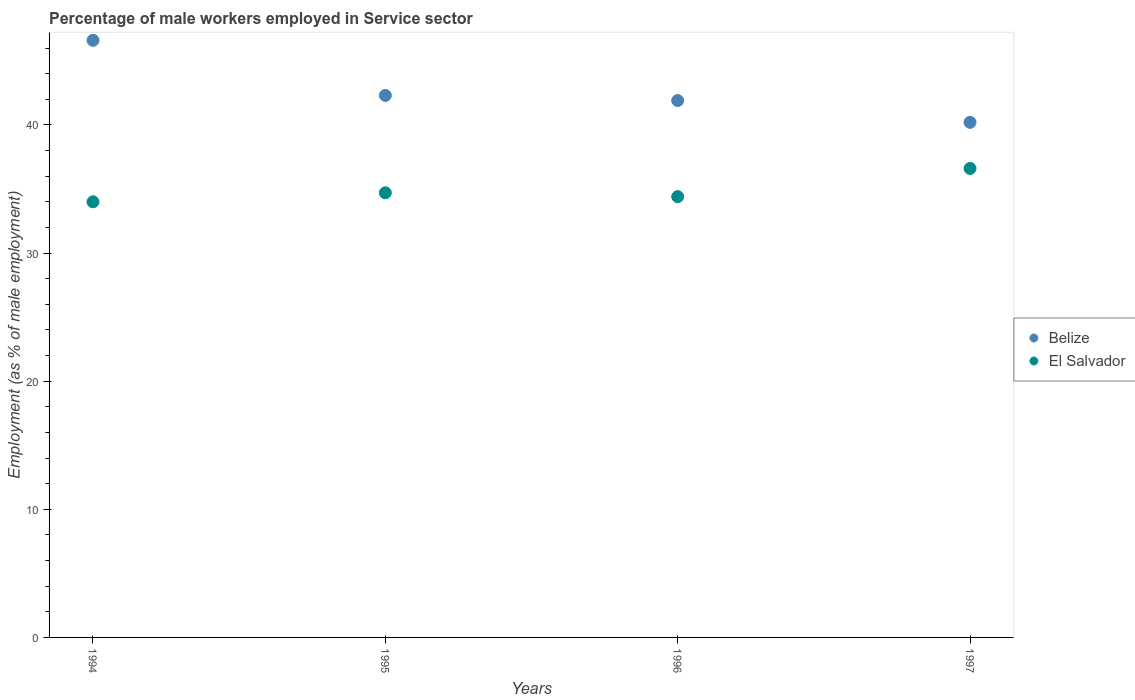How many different coloured dotlines are there?
Your response must be concise. 2. What is the percentage of male workers employed in Service sector in El Salvador in 1997?
Give a very brief answer. 36.6. Across all years, what is the maximum percentage of male workers employed in Service sector in El Salvador?
Offer a terse response. 36.6. Across all years, what is the minimum percentage of male workers employed in Service sector in Belize?
Your answer should be very brief. 40.2. What is the total percentage of male workers employed in Service sector in El Salvador in the graph?
Your answer should be very brief. 139.7. What is the difference between the percentage of male workers employed in Service sector in Belize in 1995 and that in 1997?
Provide a short and direct response. 2.1. What is the difference between the percentage of male workers employed in Service sector in Belize in 1994 and the percentage of male workers employed in Service sector in El Salvador in 1997?
Keep it short and to the point. 10. What is the average percentage of male workers employed in Service sector in Belize per year?
Offer a very short reply. 42.75. What is the ratio of the percentage of male workers employed in Service sector in Belize in 1995 to that in 1997?
Ensure brevity in your answer.  1.05. What is the difference between the highest and the second highest percentage of male workers employed in Service sector in El Salvador?
Make the answer very short. 1.9. What is the difference between the highest and the lowest percentage of male workers employed in Service sector in Belize?
Your answer should be compact. 6.4. Is the sum of the percentage of male workers employed in Service sector in El Salvador in 1994 and 1996 greater than the maximum percentage of male workers employed in Service sector in Belize across all years?
Give a very brief answer. Yes. How many dotlines are there?
Your answer should be very brief. 2. How many years are there in the graph?
Your answer should be compact. 4. Are the values on the major ticks of Y-axis written in scientific E-notation?
Your answer should be compact. No. Does the graph contain grids?
Your answer should be very brief. No. Where does the legend appear in the graph?
Your answer should be compact. Center right. How many legend labels are there?
Provide a succinct answer. 2. What is the title of the graph?
Offer a very short reply. Percentage of male workers employed in Service sector. What is the label or title of the Y-axis?
Make the answer very short. Employment (as % of male employment). What is the Employment (as % of male employment) of Belize in 1994?
Offer a very short reply. 46.6. What is the Employment (as % of male employment) of El Salvador in 1994?
Your response must be concise. 34. What is the Employment (as % of male employment) of Belize in 1995?
Your answer should be compact. 42.3. What is the Employment (as % of male employment) in El Salvador in 1995?
Offer a very short reply. 34.7. What is the Employment (as % of male employment) of Belize in 1996?
Your response must be concise. 41.9. What is the Employment (as % of male employment) in El Salvador in 1996?
Offer a terse response. 34.4. What is the Employment (as % of male employment) of Belize in 1997?
Give a very brief answer. 40.2. What is the Employment (as % of male employment) in El Salvador in 1997?
Make the answer very short. 36.6. Across all years, what is the maximum Employment (as % of male employment) in Belize?
Your response must be concise. 46.6. Across all years, what is the maximum Employment (as % of male employment) in El Salvador?
Keep it short and to the point. 36.6. Across all years, what is the minimum Employment (as % of male employment) of Belize?
Your response must be concise. 40.2. Across all years, what is the minimum Employment (as % of male employment) in El Salvador?
Give a very brief answer. 34. What is the total Employment (as % of male employment) in Belize in the graph?
Provide a succinct answer. 171. What is the total Employment (as % of male employment) of El Salvador in the graph?
Your answer should be compact. 139.7. What is the difference between the Employment (as % of male employment) of El Salvador in 1994 and that in 1995?
Your response must be concise. -0.7. What is the difference between the Employment (as % of male employment) of El Salvador in 1995 and that in 1996?
Your answer should be compact. 0.3. What is the difference between the Employment (as % of male employment) of Belize in 1995 and that in 1997?
Your response must be concise. 2.1. What is the difference between the Employment (as % of male employment) in Belize in 1996 and that in 1997?
Make the answer very short. 1.7. What is the difference between the Employment (as % of male employment) of El Salvador in 1996 and that in 1997?
Give a very brief answer. -2.2. What is the difference between the Employment (as % of male employment) of Belize in 1994 and the Employment (as % of male employment) of El Salvador in 1996?
Your response must be concise. 12.2. What is the difference between the Employment (as % of male employment) in Belize in 1996 and the Employment (as % of male employment) in El Salvador in 1997?
Offer a terse response. 5.3. What is the average Employment (as % of male employment) in Belize per year?
Your answer should be very brief. 42.75. What is the average Employment (as % of male employment) of El Salvador per year?
Offer a very short reply. 34.92. In the year 1995, what is the difference between the Employment (as % of male employment) in Belize and Employment (as % of male employment) in El Salvador?
Ensure brevity in your answer.  7.6. What is the ratio of the Employment (as % of male employment) of Belize in 1994 to that in 1995?
Ensure brevity in your answer.  1.1. What is the ratio of the Employment (as % of male employment) in El Salvador in 1994 to that in 1995?
Your answer should be very brief. 0.98. What is the ratio of the Employment (as % of male employment) of Belize in 1994 to that in 1996?
Keep it short and to the point. 1.11. What is the ratio of the Employment (as % of male employment) of El Salvador in 1994 to that in 1996?
Your answer should be very brief. 0.99. What is the ratio of the Employment (as % of male employment) in Belize in 1994 to that in 1997?
Your answer should be very brief. 1.16. What is the ratio of the Employment (as % of male employment) of El Salvador in 1994 to that in 1997?
Provide a succinct answer. 0.93. What is the ratio of the Employment (as % of male employment) in Belize in 1995 to that in 1996?
Provide a succinct answer. 1.01. What is the ratio of the Employment (as % of male employment) in El Salvador in 1995 to that in 1996?
Your answer should be compact. 1.01. What is the ratio of the Employment (as % of male employment) in Belize in 1995 to that in 1997?
Provide a short and direct response. 1.05. What is the ratio of the Employment (as % of male employment) of El Salvador in 1995 to that in 1997?
Your answer should be very brief. 0.95. What is the ratio of the Employment (as % of male employment) of Belize in 1996 to that in 1997?
Your answer should be compact. 1.04. What is the ratio of the Employment (as % of male employment) of El Salvador in 1996 to that in 1997?
Make the answer very short. 0.94. What is the difference between the highest and the second highest Employment (as % of male employment) of Belize?
Make the answer very short. 4.3. What is the difference between the highest and the second highest Employment (as % of male employment) in El Salvador?
Your answer should be compact. 1.9. What is the difference between the highest and the lowest Employment (as % of male employment) of Belize?
Offer a very short reply. 6.4. 